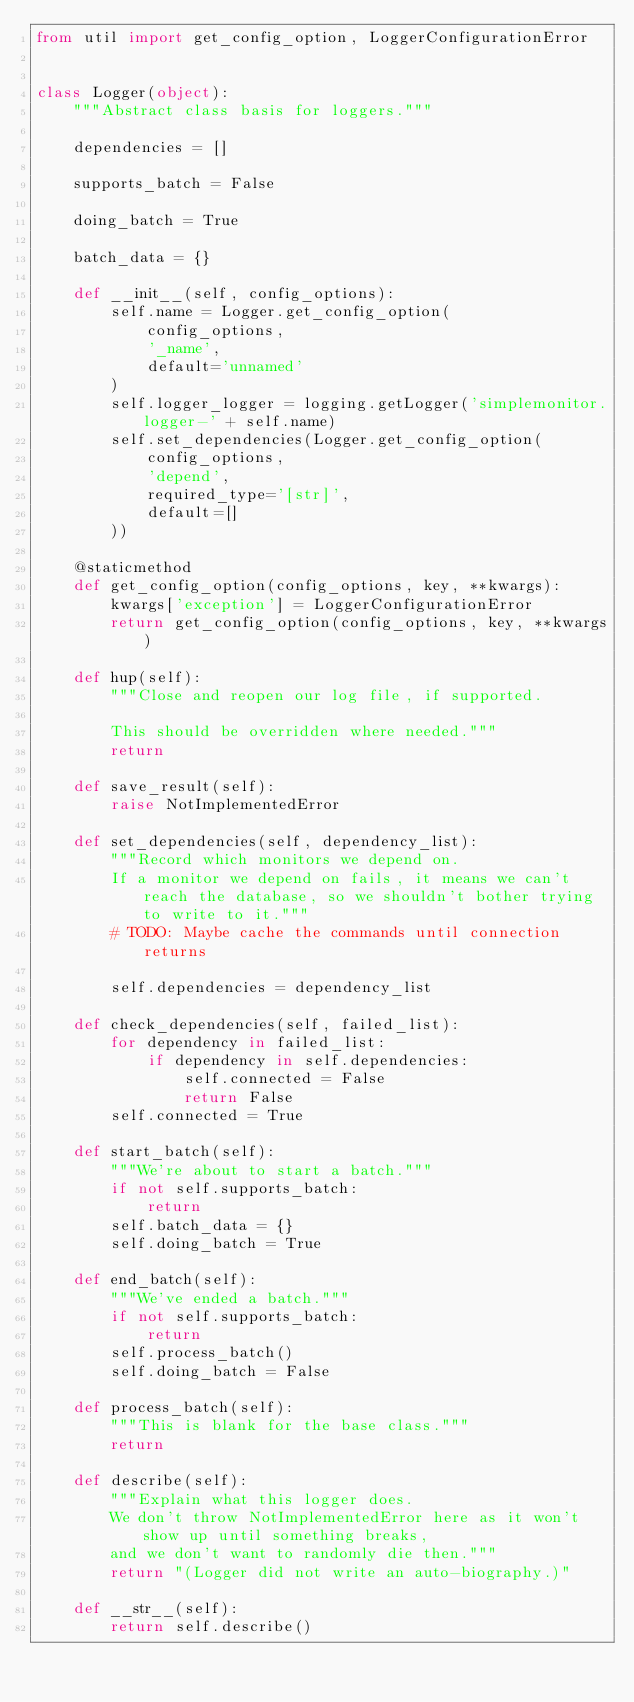Convert code to text. <code><loc_0><loc_0><loc_500><loc_500><_Python_>from util import get_config_option, LoggerConfigurationError


class Logger(object):
    """Abstract class basis for loggers."""

    dependencies = []

    supports_batch = False

    doing_batch = True

    batch_data = {}

    def __init__(self, config_options):
        self.name = Logger.get_config_option(
            config_options,
            '_name',
            default='unnamed'
        )
        self.logger_logger = logging.getLogger('simplemonitor.logger-' + self.name)
        self.set_dependencies(Logger.get_config_option(
            config_options,
            'depend',
            required_type='[str]',
            default=[]
        ))

    @staticmethod
    def get_config_option(config_options, key, **kwargs):
        kwargs['exception'] = LoggerConfigurationError
        return get_config_option(config_options, key, **kwargs)

    def hup(self):
        """Close and reopen our log file, if supported.

        This should be overridden where needed."""
        return

    def save_result(self):
        raise NotImplementedError

    def set_dependencies(self, dependency_list):
        """Record which monitors we depend on.
        If a monitor we depend on fails, it means we can't reach the database, so we shouldn't bother trying to write to it."""
        # TODO: Maybe cache the commands until connection returns

        self.dependencies = dependency_list

    def check_dependencies(self, failed_list):
        for dependency in failed_list:
            if dependency in self.dependencies:
                self.connected = False
                return False
        self.connected = True

    def start_batch(self):
        """We're about to start a batch."""
        if not self.supports_batch:
            return
        self.batch_data = {}
        self.doing_batch = True

    def end_batch(self):
        """We've ended a batch."""
        if not self.supports_batch:
            return
        self.process_batch()
        self.doing_batch = False

    def process_batch(self):
        """This is blank for the base class."""
        return

    def describe(self):
        """Explain what this logger does.
        We don't throw NotImplementedError here as it won't show up until something breaks,
        and we don't want to randomly die then."""
        return "(Logger did not write an auto-biography.)"

    def __str__(self):
        return self.describe()
</code> 